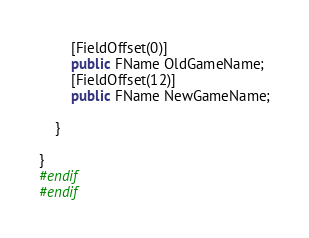Convert code to text. <code><loc_0><loc_0><loc_500><loc_500><_C#_>		[FieldOffset(0)]
		public FName OldGameName;
		[FieldOffset(12)]
		public FName NewGameName;
		
	}
	
}
#endif
#endif
</code> 